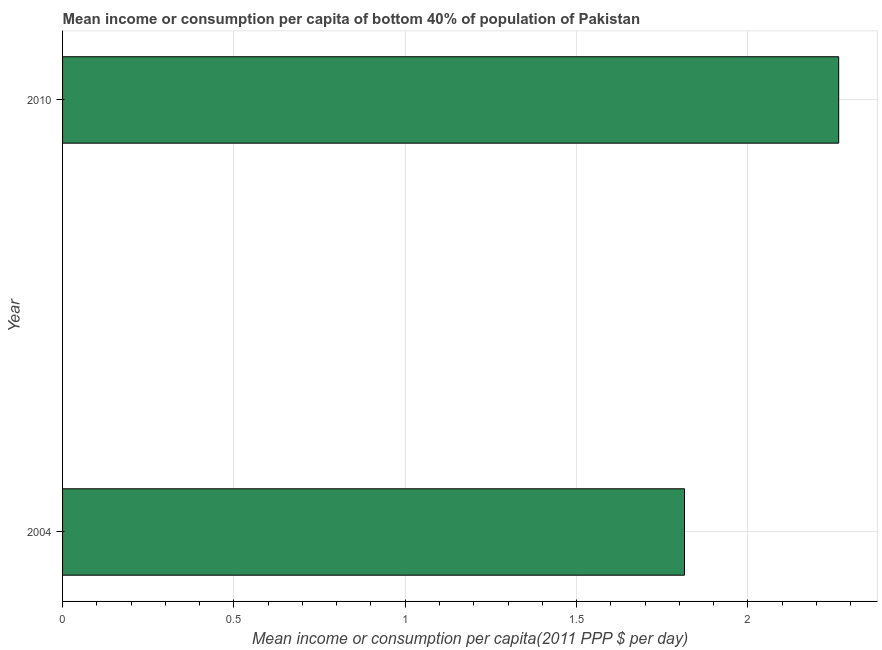Does the graph contain any zero values?
Provide a short and direct response. No. What is the title of the graph?
Your response must be concise. Mean income or consumption per capita of bottom 40% of population of Pakistan. What is the label or title of the X-axis?
Offer a very short reply. Mean income or consumption per capita(2011 PPP $ per day). What is the mean income or consumption in 2010?
Give a very brief answer. 2.27. Across all years, what is the maximum mean income or consumption?
Your answer should be very brief. 2.27. Across all years, what is the minimum mean income or consumption?
Offer a very short reply. 1.82. In which year was the mean income or consumption maximum?
Your answer should be very brief. 2010. In which year was the mean income or consumption minimum?
Keep it short and to the point. 2004. What is the sum of the mean income or consumption?
Make the answer very short. 4.08. What is the difference between the mean income or consumption in 2004 and 2010?
Provide a succinct answer. -0.45. What is the average mean income or consumption per year?
Make the answer very short. 2.04. What is the median mean income or consumption?
Keep it short and to the point. 2.04. What is the ratio of the mean income or consumption in 2004 to that in 2010?
Your answer should be compact. 0.8. Is the mean income or consumption in 2004 less than that in 2010?
Keep it short and to the point. Yes. In how many years, is the mean income or consumption greater than the average mean income or consumption taken over all years?
Your response must be concise. 1. How many bars are there?
Make the answer very short. 2. What is the difference between two consecutive major ticks on the X-axis?
Make the answer very short. 0.5. What is the Mean income or consumption per capita(2011 PPP $ per day) of 2004?
Your response must be concise. 1.82. What is the Mean income or consumption per capita(2011 PPP $ per day) in 2010?
Make the answer very short. 2.27. What is the difference between the Mean income or consumption per capita(2011 PPP $ per day) in 2004 and 2010?
Ensure brevity in your answer.  -0.45. What is the ratio of the Mean income or consumption per capita(2011 PPP $ per day) in 2004 to that in 2010?
Make the answer very short. 0.8. 